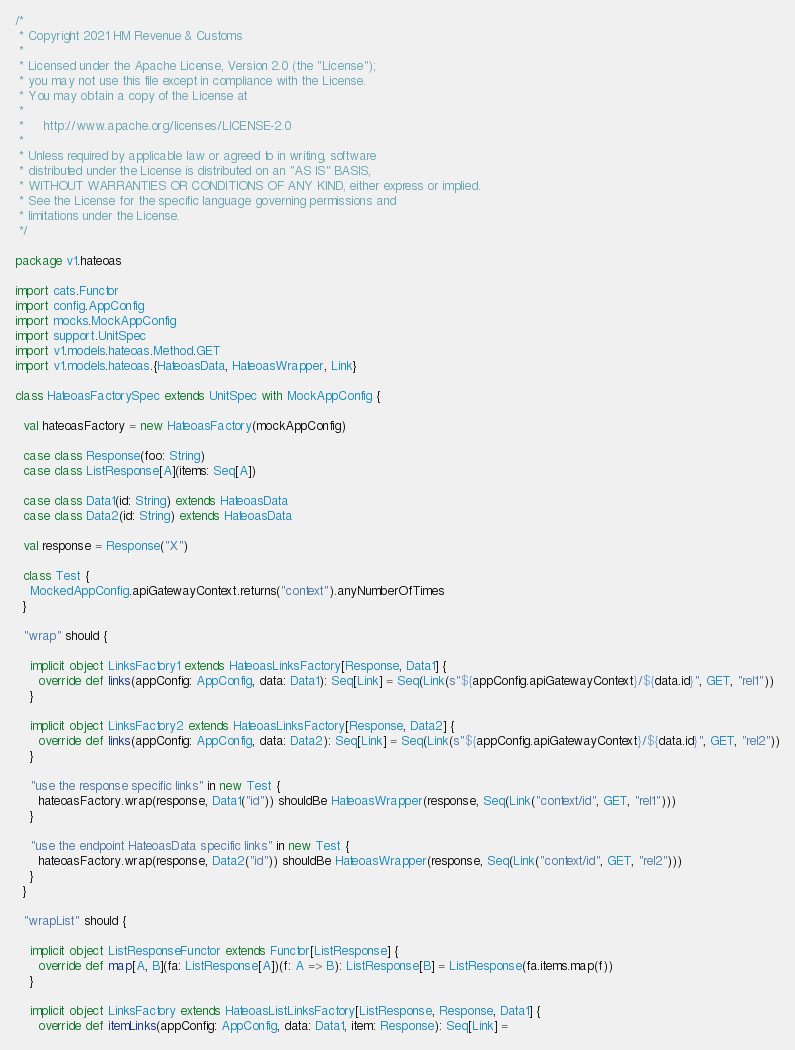<code> <loc_0><loc_0><loc_500><loc_500><_Scala_>/*
 * Copyright 2021 HM Revenue & Customs
 *
 * Licensed under the Apache License, Version 2.0 (the "License");
 * you may not use this file except in compliance with the License.
 * You may obtain a copy of the License at
 *
 *     http://www.apache.org/licenses/LICENSE-2.0
 *
 * Unless required by applicable law or agreed to in writing, software
 * distributed under the License is distributed on an "AS IS" BASIS,
 * WITHOUT WARRANTIES OR CONDITIONS OF ANY KIND, either express or implied.
 * See the License for the specific language governing permissions and
 * limitations under the License.
 */

package v1.hateoas

import cats.Functor
import config.AppConfig
import mocks.MockAppConfig
import support.UnitSpec
import v1.models.hateoas.Method.GET
import v1.models.hateoas.{HateoasData, HateoasWrapper, Link}

class HateoasFactorySpec extends UnitSpec with MockAppConfig {

  val hateoasFactory = new HateoasFactory(mockAppConfig)

  case class Response(foo: String)
  case class ListResponse[A](items: Seq[A])

  case class Data1(id: String) extends HateoasData
  case class Data2(id: String) extends HateoasData

  val response = Response("X")

  class Test {
    MockedAppConfig.apiGatewayContext.returns("context").anyNumberOfTimes
  }

  "wrap" should {

    implicit object LinksFactory1 extends HateoasLinksFactory[Response, Data1] {
      override def links(appConfig: AppConfig, data: Data1): Seq[Link] = Seq(Link(s"${appConfig.apiGatewayContext}/${data.id}", GET, "rel1"))
    }

    implicit object LinksFactory2 extends HateoasLinksFactory[Response, Data2] {
      override def links(appConfig: AppConfig, data: Data2): Seq[Link] = Seq(Link(s"${appConfig.apiGatewayContext}/${data.id}", GET, "rel2"))
    }

    "use the response specific links" in new Test {
      hateoasFactory.wrap(response, Data1("id")) shouldBe HateoasWrapper(response, Seq(Link("context/id", GET, "rel1")))
    }

    "use the endpoint HateoasData specific links" in new Test {
      hateoasFactory.wrap(response, Data2("id")) shouldBe HateoasWrapper(response, Seq(Link("context/id", GET, "rel2")))
    }
  }

  "wrapList" should {

    implicit object ListResponseFunctor extends Functor[ListResponse] {
      override def map[A, B](fa: ListResponse[A])(f: A => B): ListResponse[B] = ListResponse(fa.items.map(f))
    }

    implicit object LinksFactory extends HateoasListLinksFactory[ListResponse, Response, Data1] {
      override def itemLinks(appConfig: AppConfig, data: Data1, item: Response): Seq[Link] =</code> 